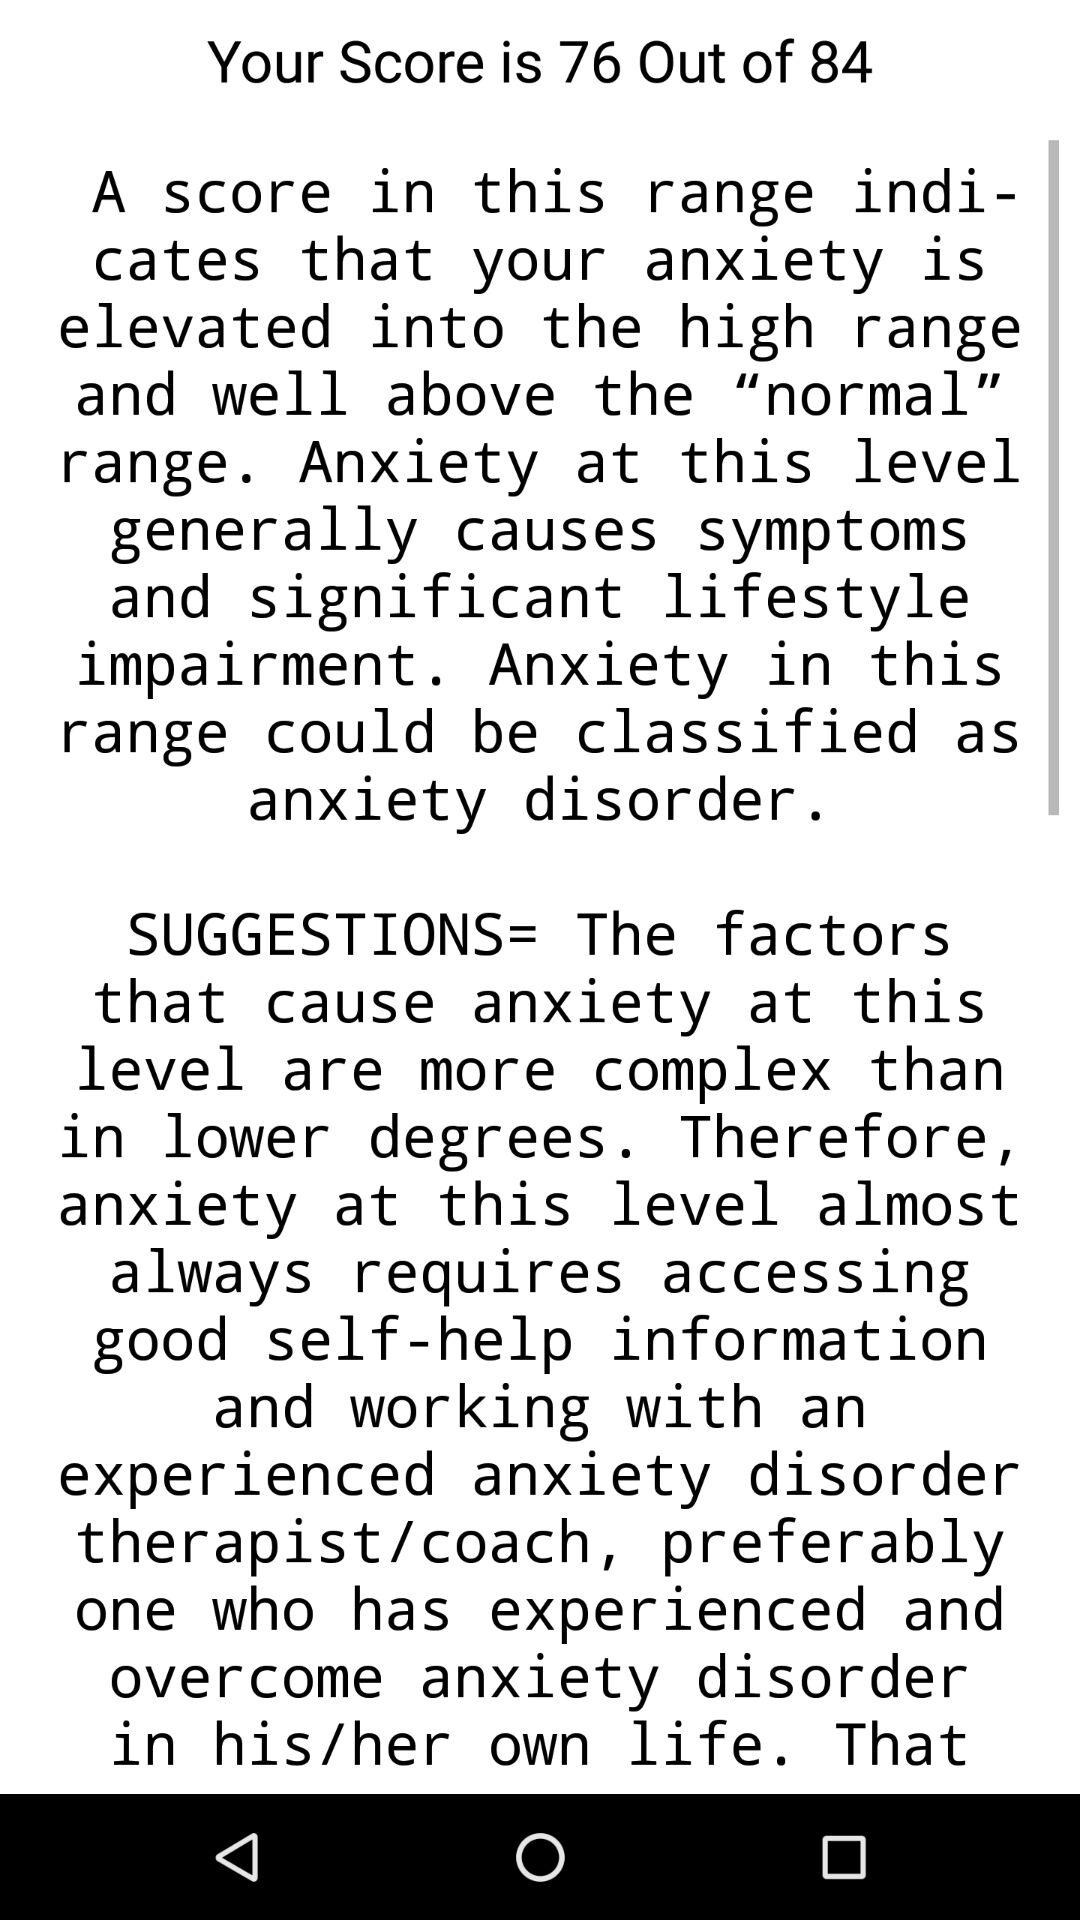When was the test taken?
When the provided information is insufficient, respond with <no answer>. <no answer> 